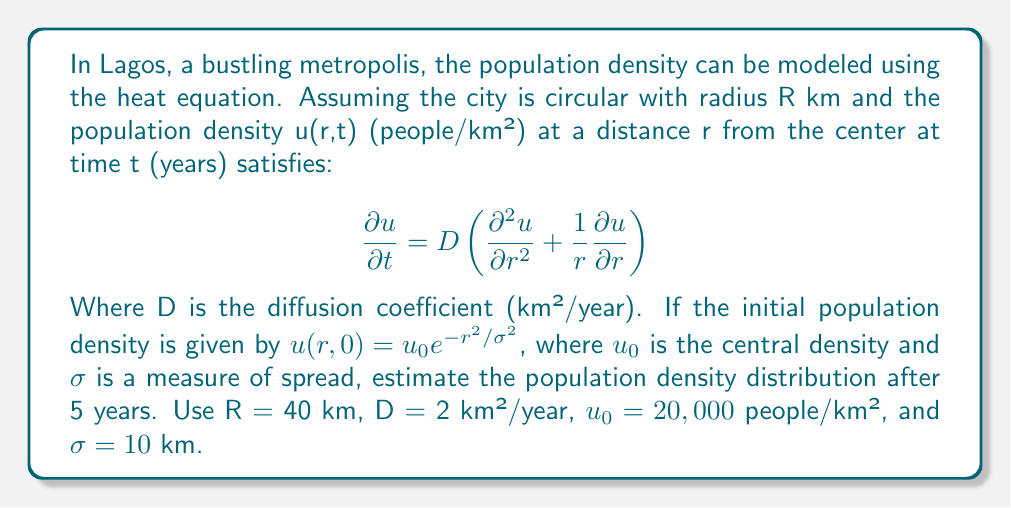Solve this math problem. To solve this problem, we'll use the solution to the heat equation in polar coordinates:

1) The general solution for the heat equation in this case is:

   $$u(r,t) = \frac{u_0\sigma^2}{\sigma^2 + 4Dt} \exp\left(-\frac{r^2}{\sigma^2 + 4Dt}\right)$$

2) We need to substitute the given values:
   t = 5 years
   D = 2 km²/year
   $u_0 = 20,000$ people/km²
   σ = 10 km

3) First, let's calculate $\sigma^2 + 4Dt$:
   $\sigma^2 + 4Dt = 10^2 + 4(2)(5) = 100 + 40 = 140$ km²

4) Now we can substitute this and the other values into our solution:

   $$u(r,5) = \frac{20,000 \cdot 100}{140} \exp\left(-\frac{r^2}{140}\right)$$

5) Simplify:

   $$u(r,5) = 14,285.71 \exp\left(-\frac{r^2}{140}\right)$$

This gives us the population density distribution after 5 years as a function of r, the distance from the city center.

6) To visualize this, we can calculate the density at a few points:
   At r = 0 km (city center): u(0,5) ≈ 14,286 people/km²
   At r = 10 km: u(10,5) ≈ 10,512 people/km²
   At r = 20 km: u(20,5) ≈ 5,697 people/km²
   At r = 40 km (city edge): u(40,5) ≈ 836 people/km²

This shows how the population density decreases as we move away from the city center.
Answer: $u(r,5) = 14,285.71 \exp(-r^2/140)$ people/km² 